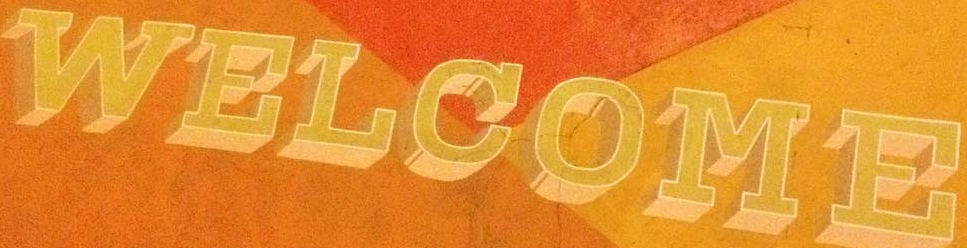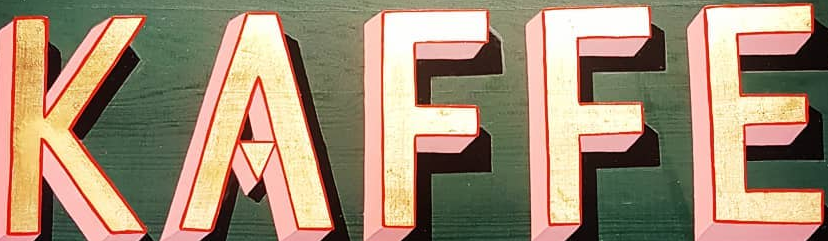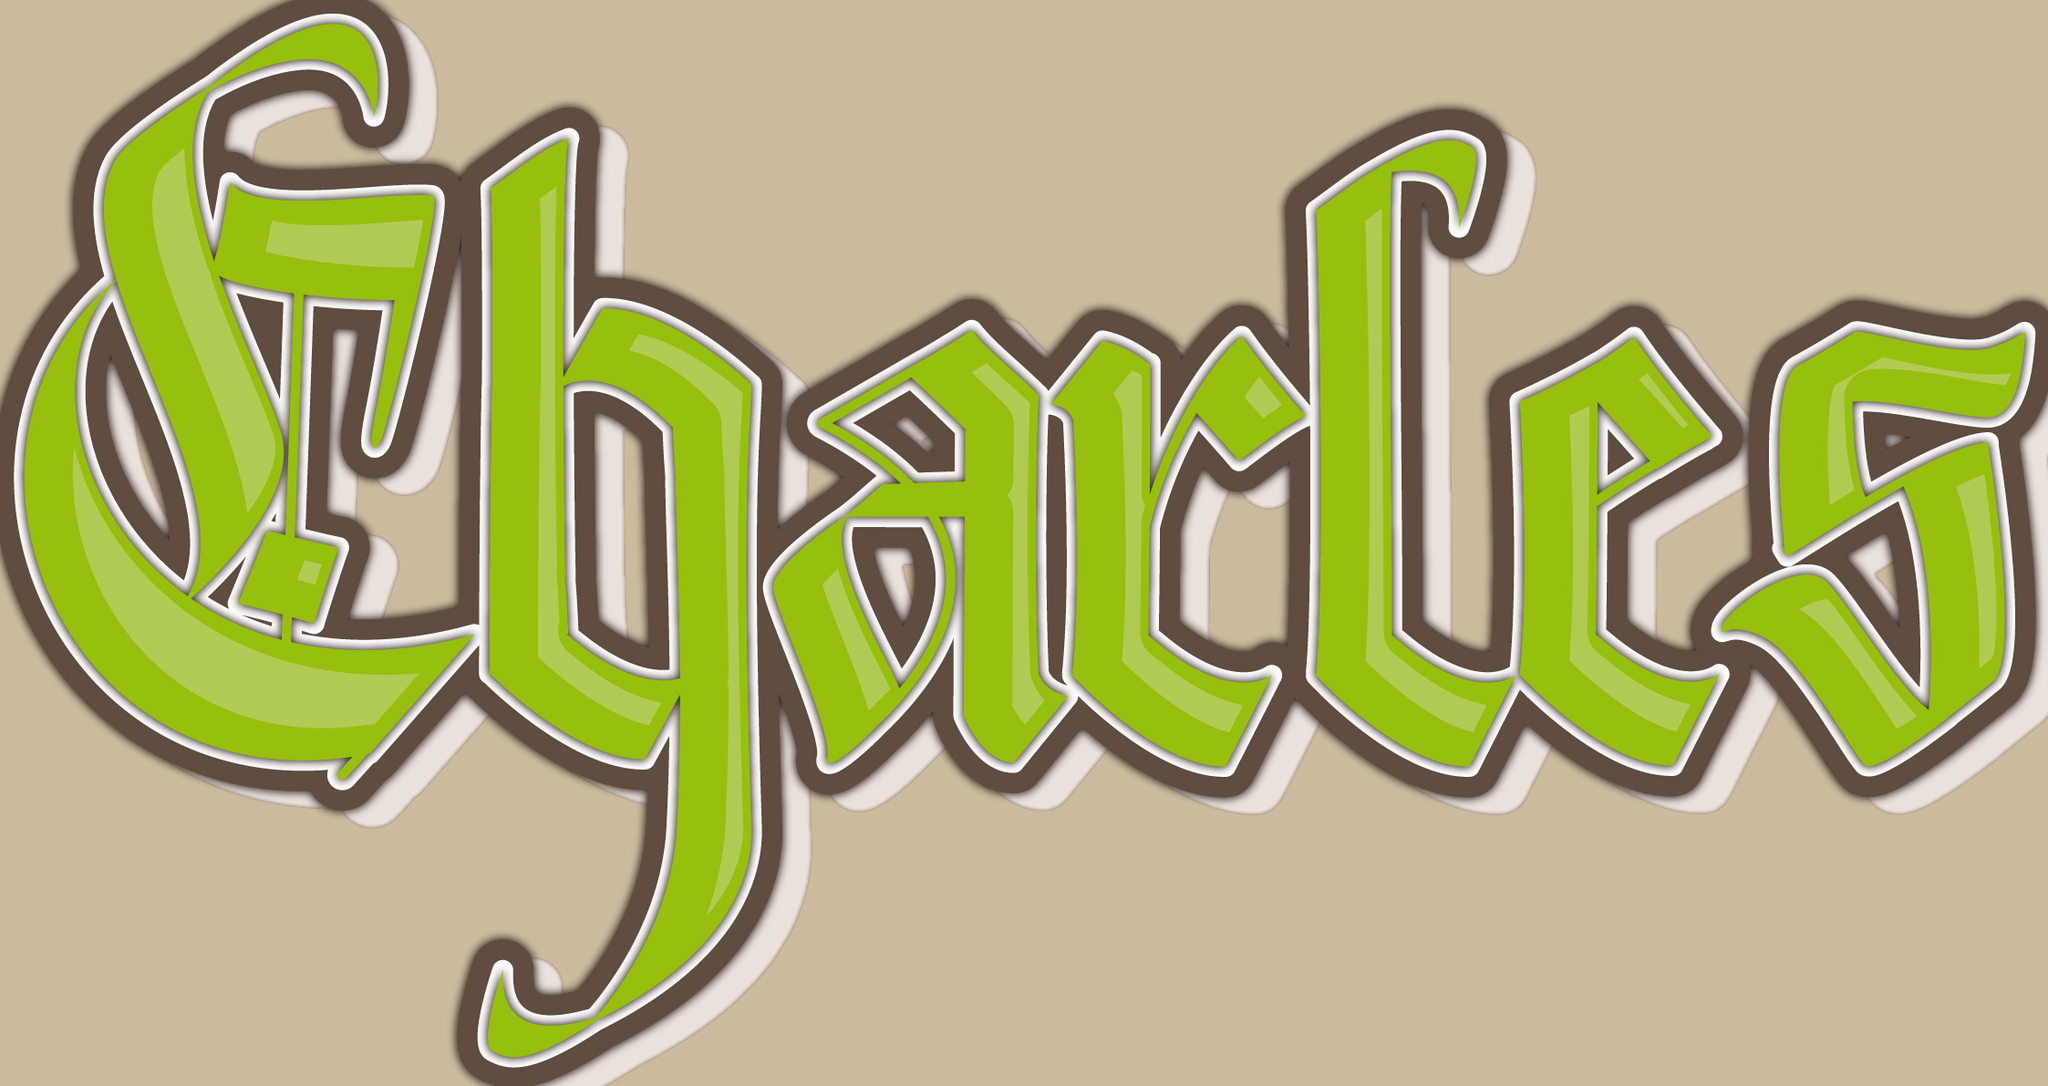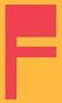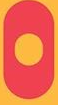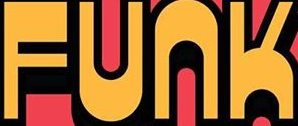What words can you see in these images in sequence, separated by a semicolon? WELCOME; KAFFE; Charles; F; O; FUNK 